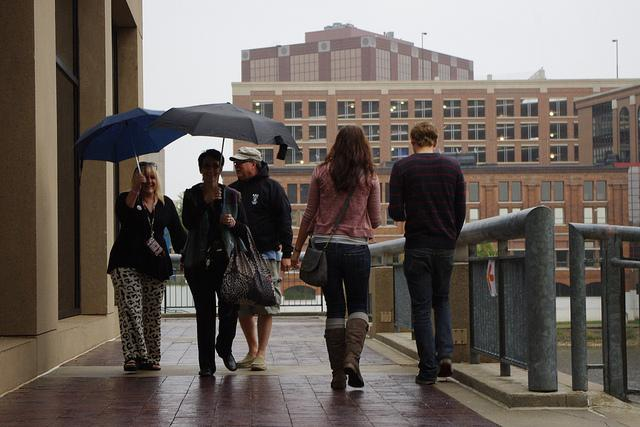What problem are the two people on the right facing? getting wet 